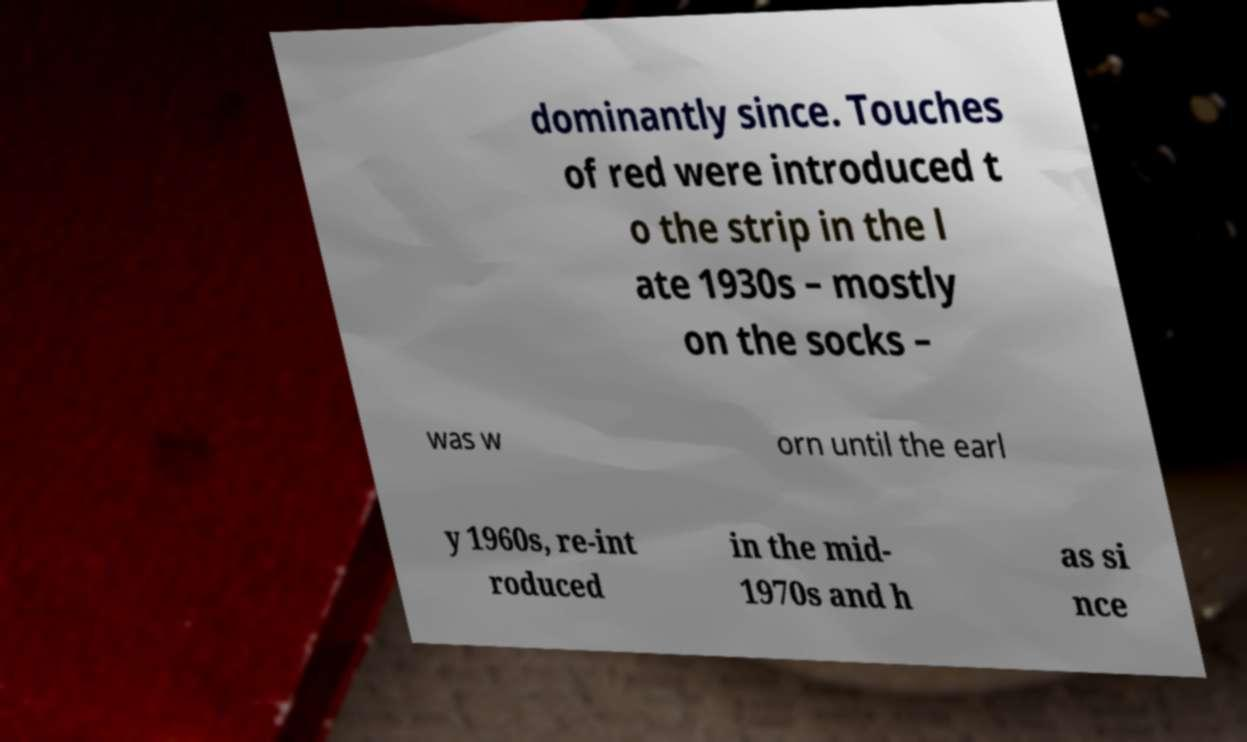I need the written content from this picture converted into text. Can you do that? dominantly since. Touches of red were introduced t o the strip in the l ate 1930s – mostly on the socks – was w orn until the earl y 1960s, re-int roduced in the mid- 1970s and h as si nce 